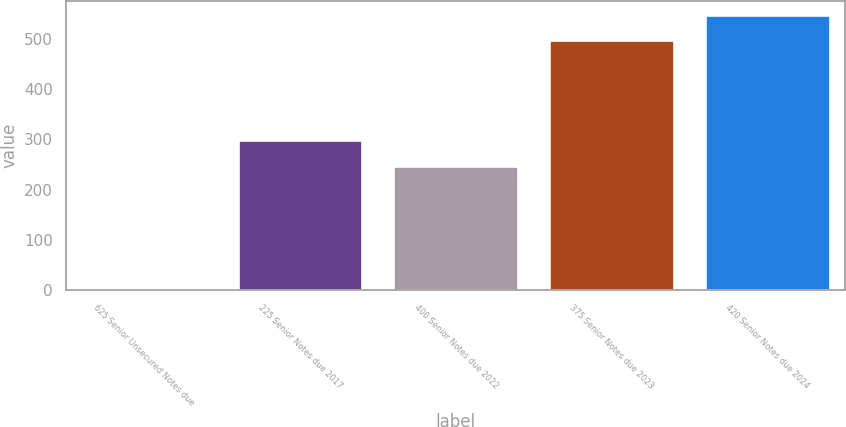Convert chart to OTSL. <chart><loc_0><loc_0><loc_500><loc_500><bar_chart><fcel>625 Senior Unsecured Notes due<fcel>225 Senior Notes due 2017<fcel>400 Senior Notes due 2022<fcel>375 Senior Notes due 2023<fcel>420 Senior Notes due 2024<nl><fcel>0.58<fcel>299.6<fcel>247.7<fcel>498.8<fcel>548.65<nl></chart> 